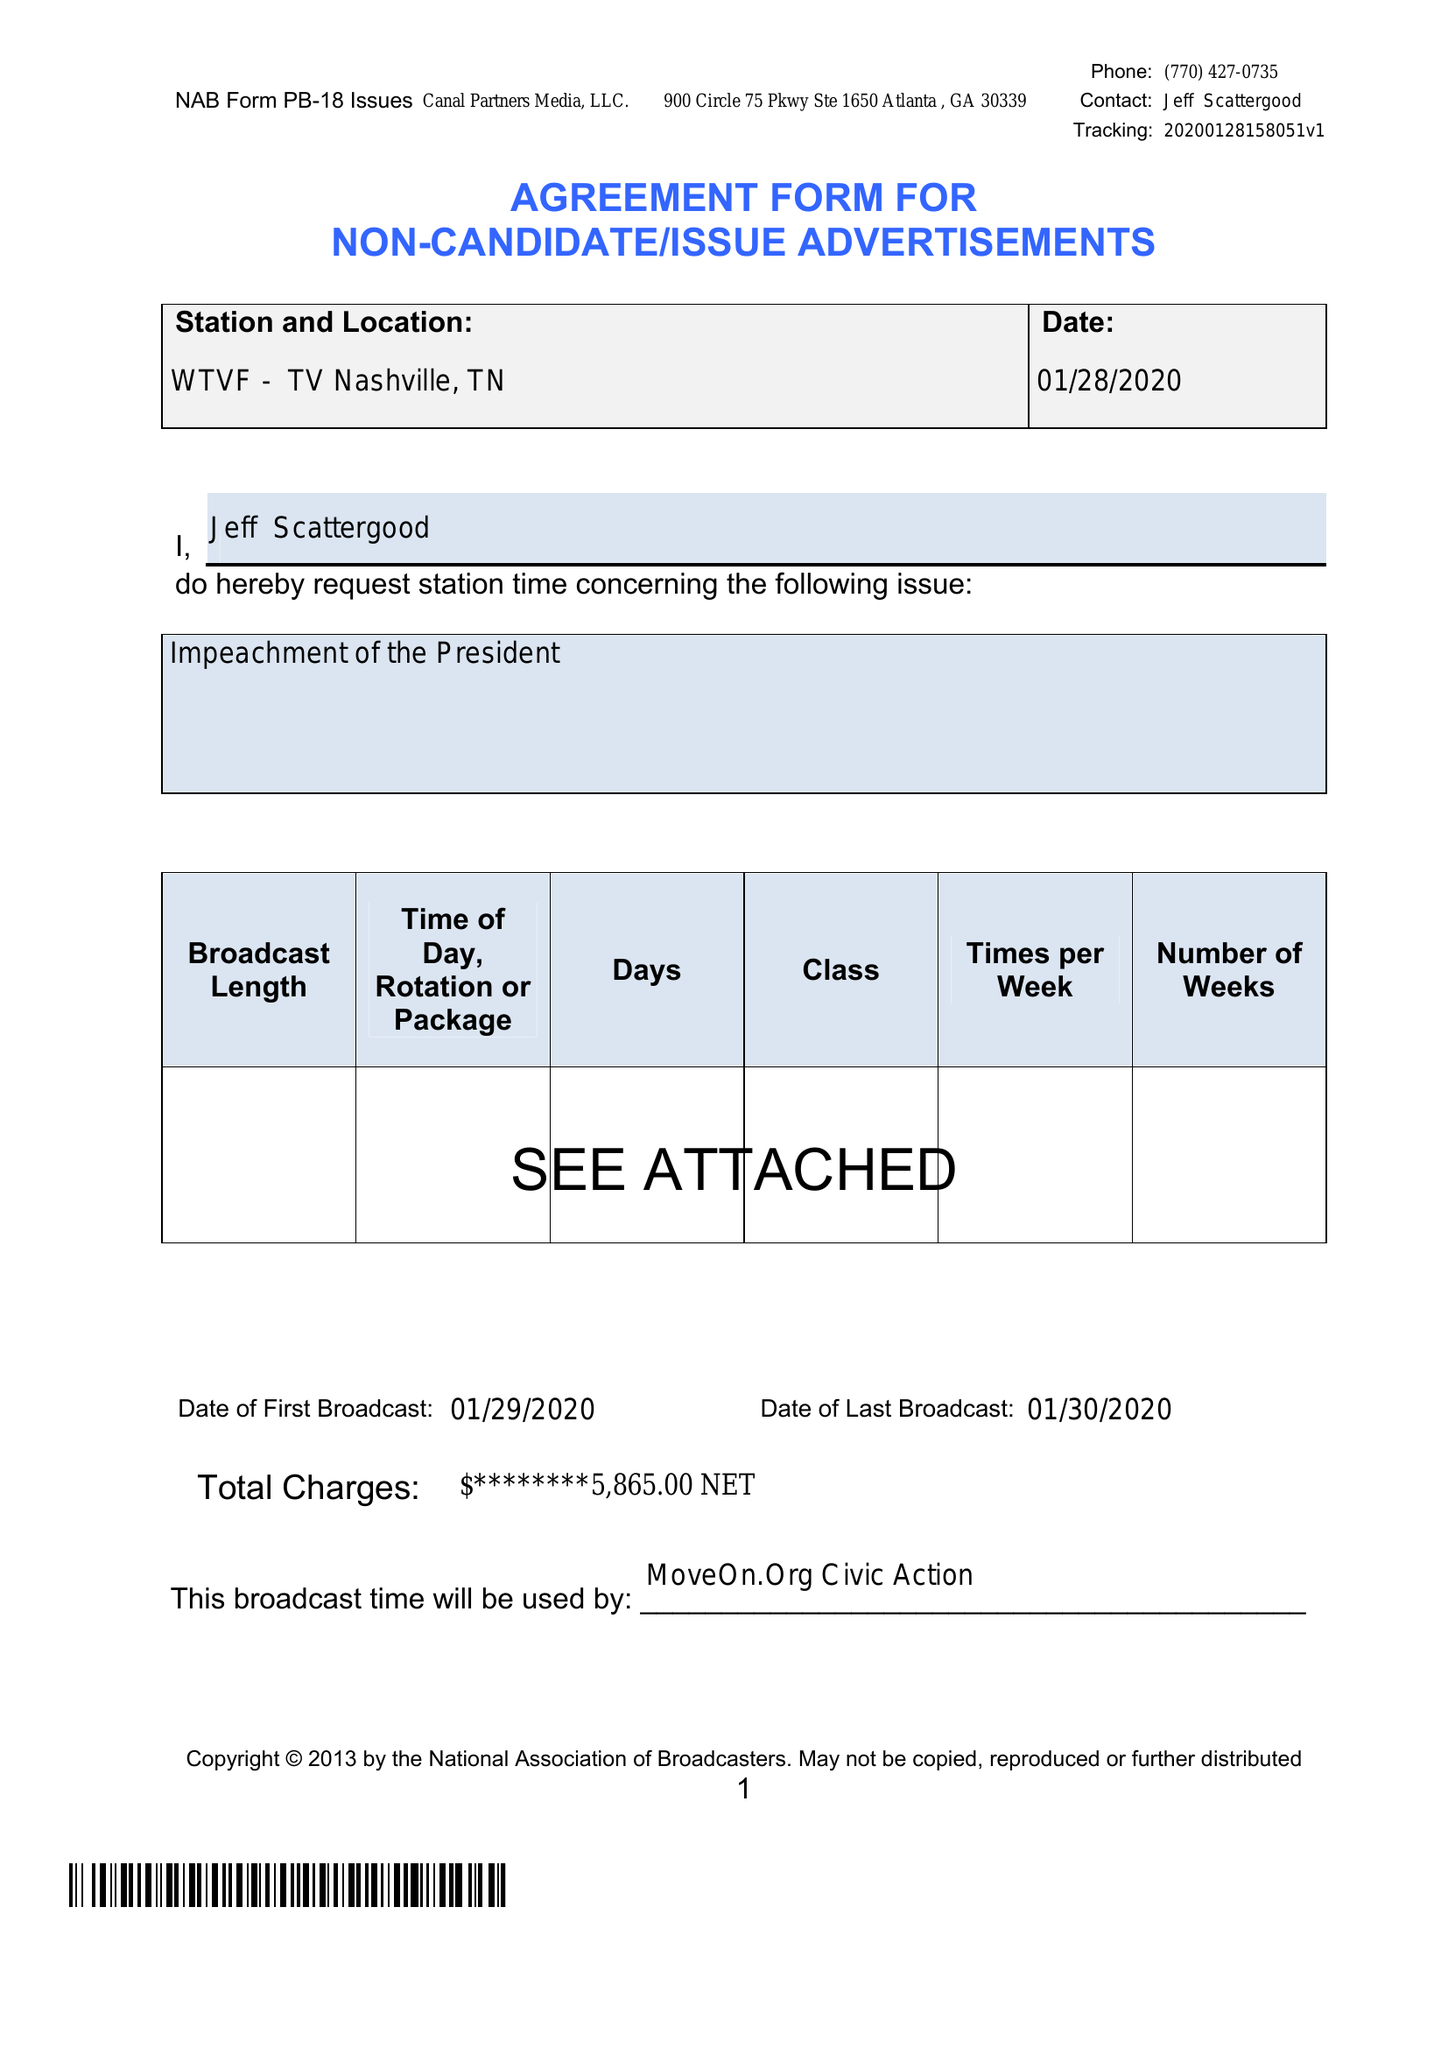What is the value for the flight_to?
Answer the question using a single word or phrase. 01/30/20 